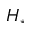Convert formula to latex. <formula><loc_0><loc_0><loc_500><loc_500>H _ { \ast }</formula> 